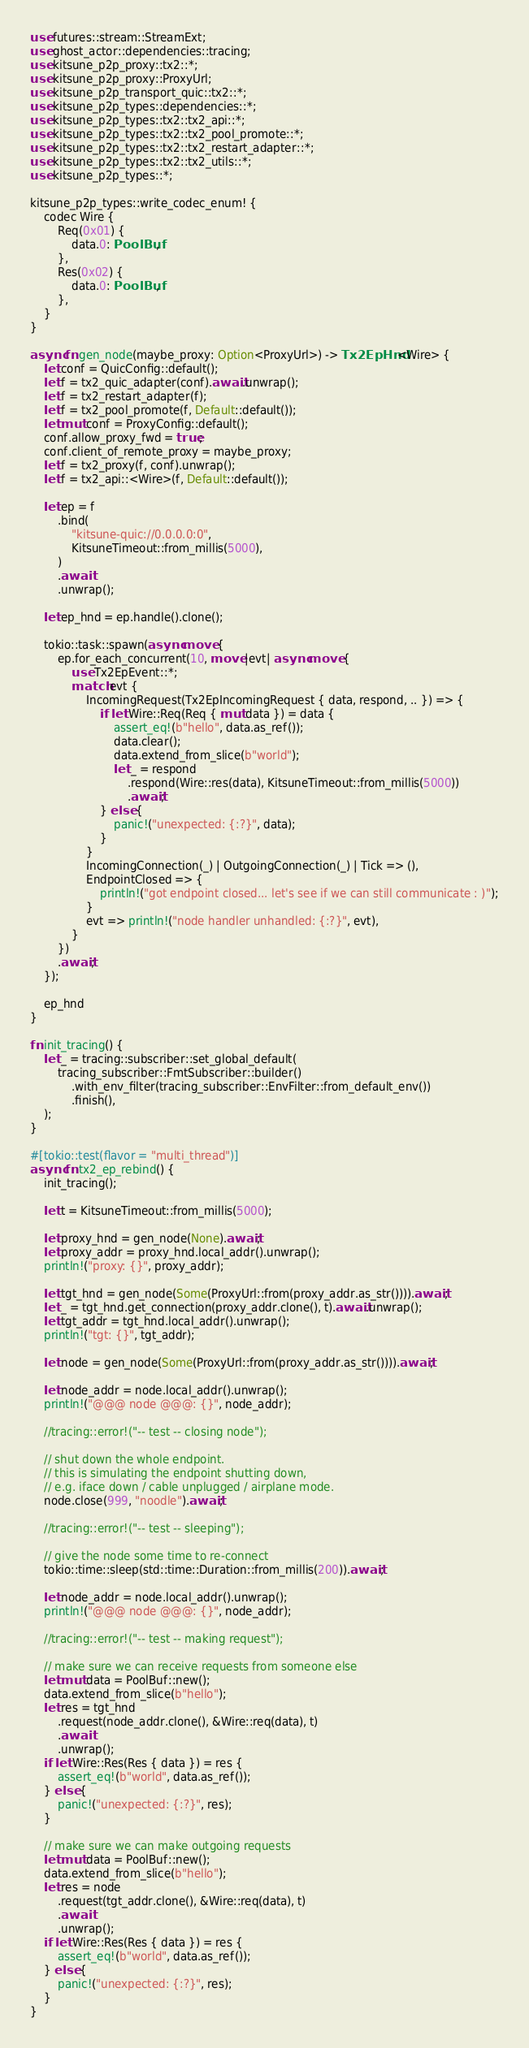<code> <loc_0><loc_0><loc_500><loc_500><_Rust_>use futures::stream::StreamExt;
use ghost_actor::dependencies::tracing;
use kitsune_p2p_proxy::tx2::*;
use kitsune_p2p_proxy::ProxyUrl;
use kitsune_p2p_transport_quic::tx2::*;
use kitsune_p2p_types::dependencies::*;
use kitsune_p2p_types::tx2::tx2_api::*;
use kitsune_p2p_types::tx2::tx2_pool_promote::*;
use kitsune_p2p_types::tx2::tx2_restart_adapter::*;
use kitsune_p2p_types::tx2::tx2_utils::*;
use kitsune_p2p_types::*;

kitsune_p2p_types::write_codec_enum! {
    codec Wire {
        Req(0x01) {
            data.0: PoolBuf,
        },
        Res(0x02) {
            data.0: PoolBuf,
        },
    }
}

async fn gen_node(maybe_proxy: Option<ProxyUrl>) -> Tx2EpHnd<Wire> {
    let conf = QuicConfig::default();
    let f = tx2_quic_adapter(conf).await.unwrap();
    let f = tx2_restart_adapter(f);
    let f = tx2_pool_promote(f, Default::default());
    let mut conf = ProxyConfig::default();
    conf.allow_proxy_fwd = true;
    conf.client_of_remote_proxy = maybe_proxy;
    let f = tx2_proxy(f, conf).unwrap();
    let f = tx2_api::<Wire>(f, Default::default());

    let ep = f
        .bind(
            "kitsune-quic://0.0.0.0:0",
            KitsuneTimeout::from_millis(5000),
        )
        .await
        .unwrap();

    let ep_hnd = ep.handle().clone();

    tokio::task::spawn(async move {
        ep.for_each_concurrent(10, move |evt| async move {
            use Tx2EpEvent::*;
            match evt {
                IncomingRequest(Tx2EpIncomingRequest { data, respond, .. }) => {
                    if let Wire::Req(Req { mut data }) = data {
                        assert_eq!(b"hello", data.as_ref());
                        data.clear();
                        data.extend_from_slice(b"world");
                        let _ = respond
                            .respond(Wire::res(data), KitsuneTimeout::from_millis(5000))
                            .await;
                    } else {
                        panic!("unexpected: {:?}", data);
                    }
                }
                IncomingConnection(_) | OutgoingConnection(_) | Tick => (),
                EndpointClosed => {
                    println!("got endpoint closed... let's see if we can still communicate : )");
                }
                evt => println!("node handler unhandled: {:?}", evt),
            }
        })
        .await;
    });

    ep_hnd
}

fn init_tracing() {
    let _ = tracing::subscriber::set_global_default(
        tracing_subscriber::FmtSubscriber::builder()
            .with_env_filter(tracing_subscriber::EnvFilter::from_default_env())
            .finish(),
    );
}

#[tokio::test(flavor = "multi_thread")]
async fn tx2_ep_rebind() {
    init_tracing();

    let t = KitsuneTimeout::from_millis(5000);

    let proxy_hnd = gen_node(None).await;
    let proxy_addr = proxy_hnd.local_addr().unwrap();
    println!("proxy: {}", proxy_addr);

    let tgt_hnd = gen_node(Some(ProxyUrl::from(proxy_addr.as_str()))).await;
    let _ = tgt_hnd.get_connection(proxy_addr.clone(), t).await.unwrap();
    let tgt_addr = tgt_hnd.local_addr().unwrap();
    println!("tgt: {}", tgt_addr);

    let node = gen_node(Some(ProxyUrl::from(proxy_addr.as_str()))).await;

    let node_addr = node.local_addr().unwrap();
    println!("@@@ node @@@: {}", node_addr);

    //tracing::error!("-- test -- closing node");

    // shut down the whole endpoint.
    // this is simulating the endpoint shutting down,
    // e.g. iface down / cable unplugged / airplane mode.
    node.close(999, "noodle").await;

    //tracing::error!("-- test -- sleeping");

    // give the node some time to re-connect
    tokio::time::sleep(std::time::Duration::from_millis(200)).await;

    let node_addr = node.local_addr().unwrap();
    println!("@@@ node @@@: {}", node_addr);

    //tracing::error!("-- test -- making request");

    // make sure we can receive requests from someone else
    let mut data = PoolBuf::new();
    data.extend_from_slice(b"hello");
    let res = tgt_hnd
        .request(node_addr.clone(), &Wire::req(data), t)
        .await
        .unwrap();
    if let Wire::Res(Res { data }) = res {
        assert_eq!(b"world", data.as_ref());
    } else {
        panic!("unexpected: {:?}", res);
    }

    // make sure we can make outgoing requests
    let mut data = PoolBuf::new();
    data.extend_from_slice(b"hello");
    let res = node
        .request(tgt_addr.clone(), &Wire::req(data), t)
        .await
        .unwrap();
    if let Wire::Res(Res { data }) = res {
        assert_eq!(b"world", data.as_ref());
    } else {
        panic!("unexpected: {:?}", res);
    }
}
</code> 